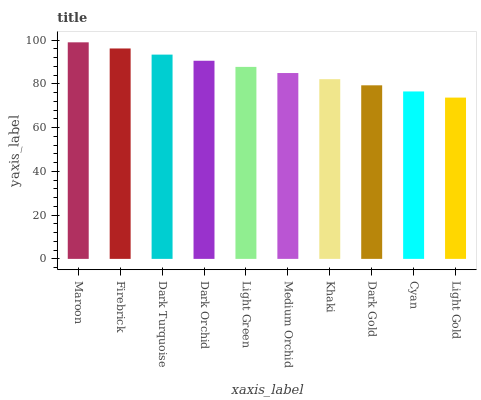Is Maroon the maximum?
Answer yes or no. Yes. Is Firebrick the minimum?
Answer yes or no. No. Is Firebrick the maximum?
Answer yes or no. No. Is Maroon greater than Firebrick?
Answer yes or no. Yes. Is Firebrick less than Maroon?
Answer yes or no. Yes. Is Firebrick greater than Maroon?
Answer yes or no. No. Is Maroon less than Firebrick?
Answer yes or no. No. Is Light Green the high median?
Answer yes or no. Yes. Is Medium Orchid the low median?
Answer yes or no. Yes. Is Maroon the high median?
Answer yes or no. No. Is Dark Turquoise the low median?
Answer yes or no. No. 